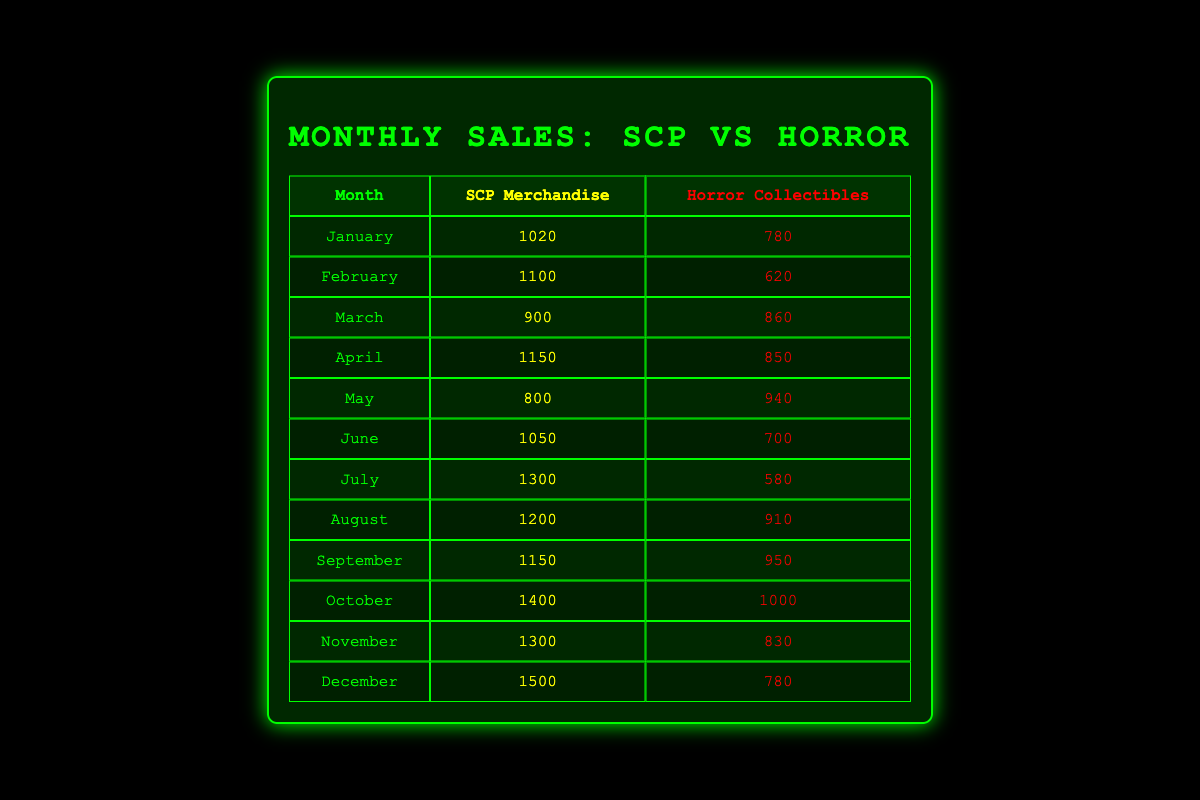What is the highest sales month for SCP merchandise? The SCP merchandise sales peak at 1500 units, which occurs in December when checking the values listed for each month.
Answer: December In which month did horror collectibles have the lowest sales? By reviewing the sales figures for horror collectibles, February shows the lowest sales at 620 units.
Answer: February What is the total sales for SCP merchandise from January to March? The sales for SCP merchandise from January (1020), February (1100), and March (900) add up to 3020. This is calculated as 1020 + 1100 + 900 = 3020.
Answer: 3020 Did SCP merchandise sales ever fall below horror collectibles sales? Yes, looking at the monthly sales, SCP merchandise sales fell below horror collectibles sales in March (900 for SCP vs. 860 for horror collectibles).
Answer: Yes What is the difference in sales between SCP merchandise and horror collectibles in October? In October, SCP merchandise sales are 1400 and horror collectibles sales are 1000. The difference is calculated as 1400 - 1000 = 400.
Answer: 400 In which month did SCP merchandise sales exceed horror collectibles by the largest amount? To find the month with the largest difference, we calculate the differences: January (240), February (480), March (40), April (300), May (100), June (350), July (720), August (290), September (200), October (400), November (470), and December (720). The largest difference occurs in July with 720 more sales than horror collectibles.
Answer: July What was the average monthly sales for horror collectibles over the year? The average is calculated by summing the monthly sales for horror collectibles (780 + 620 + 860 + 850 + 940 + 700 + 580 + 910 + 950 + 1000 + 830 + 780 = 10360) and dividing by 12 months (10360 / 12 = 863.33).
Answer: 863.33 How many months did SCP merchandise sales exceed 1000 units? SCP merchandise sales exceeded 1000 units in January (1020), February (1100), April (1150), July (1300), August (1200), October (1400), November (1300), and December (1500). This gives a total of 8 months.
Answer: 8 Was there any month where horror collectibles sales outperformed SCP merchandise? Yes, specifically in March, horror collectibles sales were higher with 860 compared to 900 for SCP merchandise.
Answer: Yes 